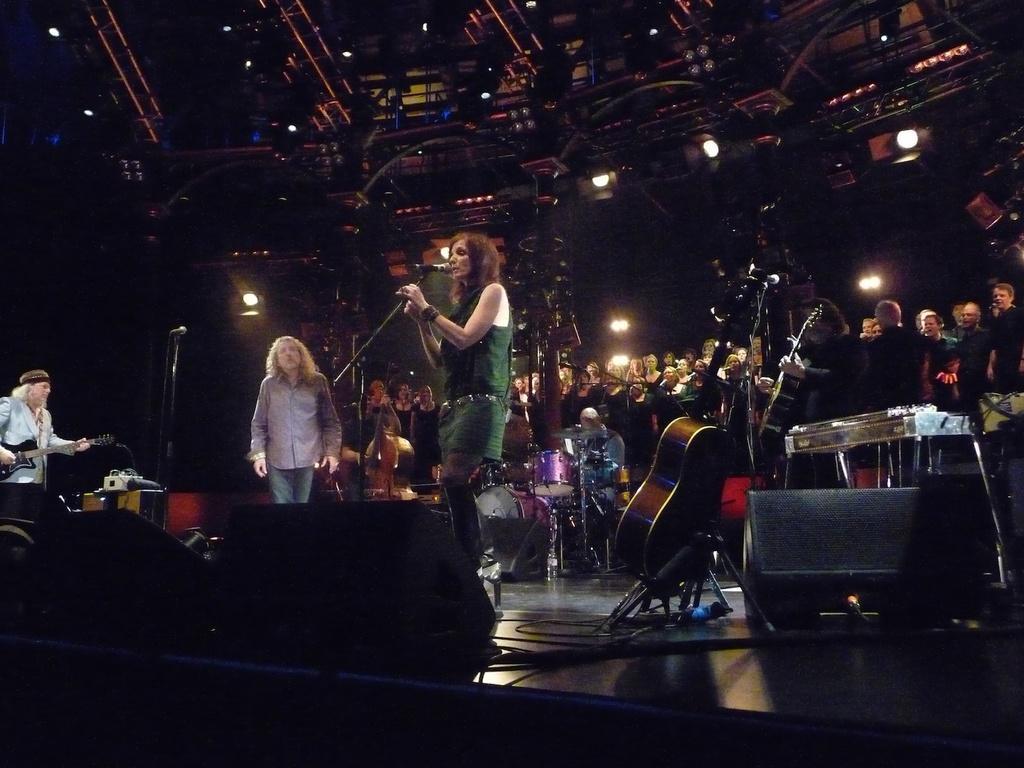Can you describe this image briefly? In this image we can see four people performing, on left side man is playing a guitar, in the middle the woman is singing as we can see, on the right side we can see a man playing a guitar, in the background group of people looking at the performance, in front we can see one guitar and in the background there are some musical instruments like drums and cymbal, on the top of the image we can see some lights here. 